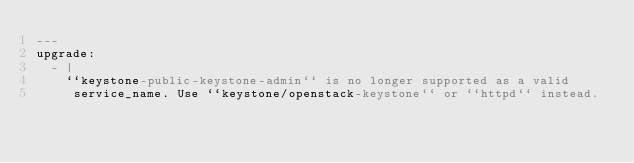<code> <loc_0><loc_0><loc_500><loc_500><_YAML_>---
upgrade:
  - |
    ``keystone-public-keystone-admin`` is no longer supported as a valid
     service_name. Use ``keystone/openstack-keystone`` or ``httpd`` instead.
</code> 